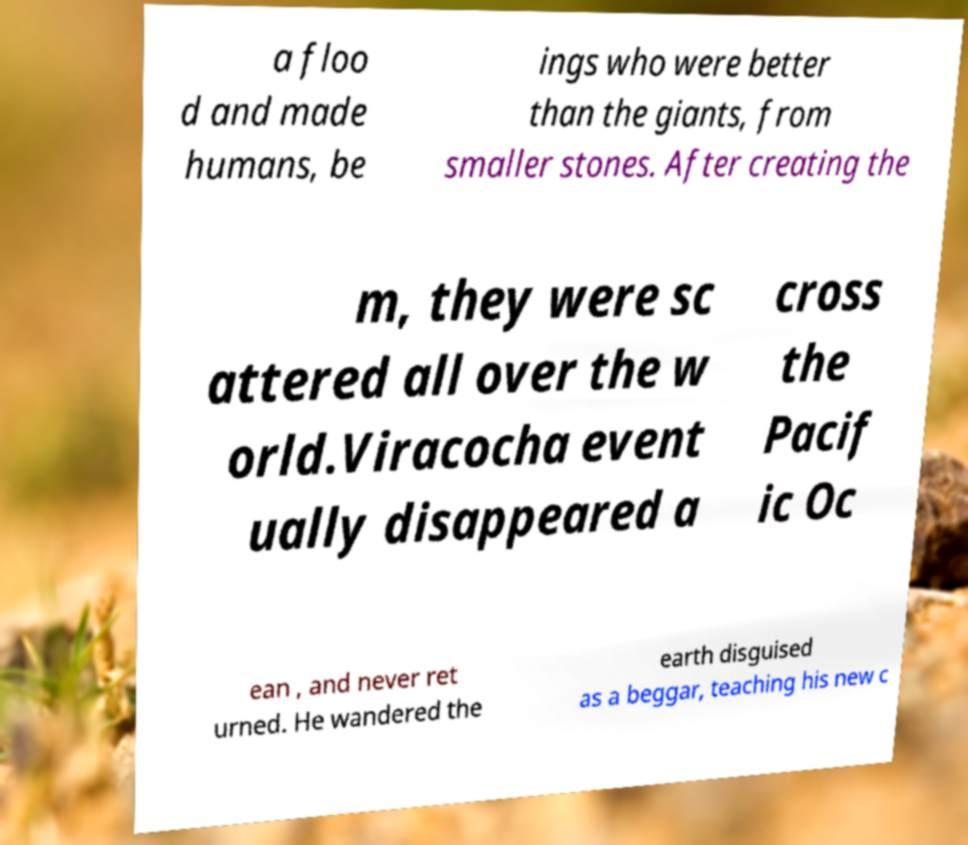For documentation purposes, I need the text within this image transcribed. Could you provide that? a floo d and made humans, be ings who were better than the giants, from smaller stones. After creating the m, they were sc attered all over the w orld.Viracocha event ually disappeared a cross the Pacif ic Oc ean , and never ret urned. He wandered the earth disguised as a beggar, teaching his new c 